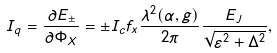Convert formula to latex. <formula><loc_0><loc_0><loc_500><loc_500>I _ { q } = \frac { \partial E _ { \pm } } { \partial \Phi _ { X } } = \pm I _ { c } f _ { x } \frac { \lambda ^ { 2 } ( \alpha , g ) } { 2 \pi } \frac { E _ { J } } { \sqrt { \varepsilon ^ { 2 } + \Delta ^ { 2 } } } ,</formula> 